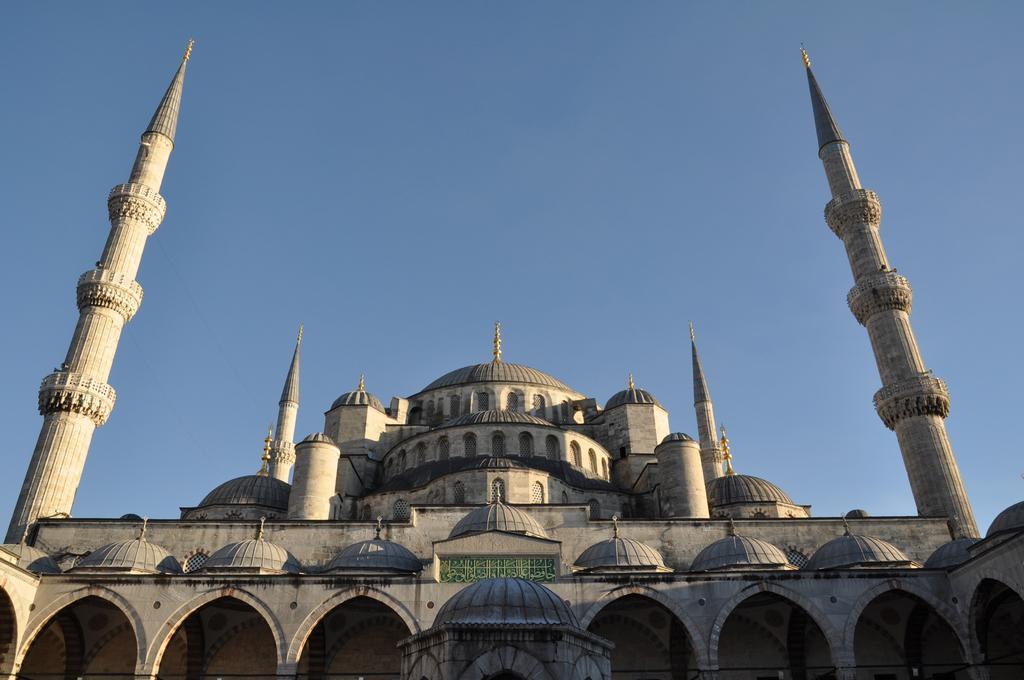In one or two sentences, can you explain what this image depicts? In this image we can see a building. In the background there is sky. 